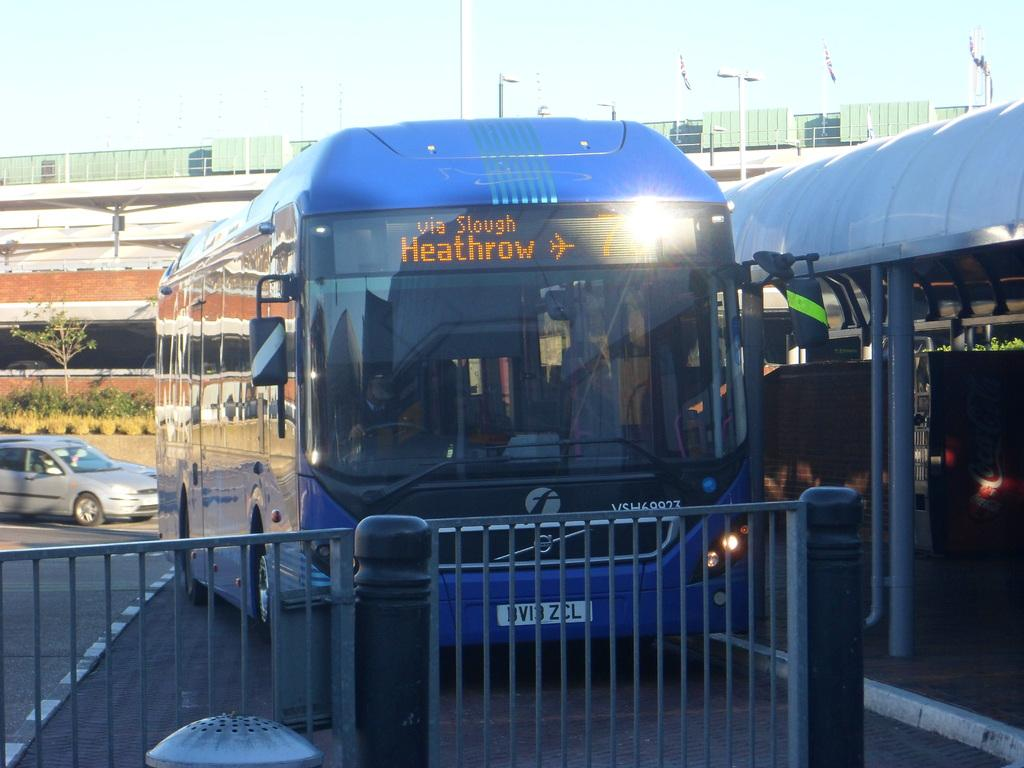Provide a one-sentence caption for the provided image. Bus service is available to Heathrow Airport via Slough. 